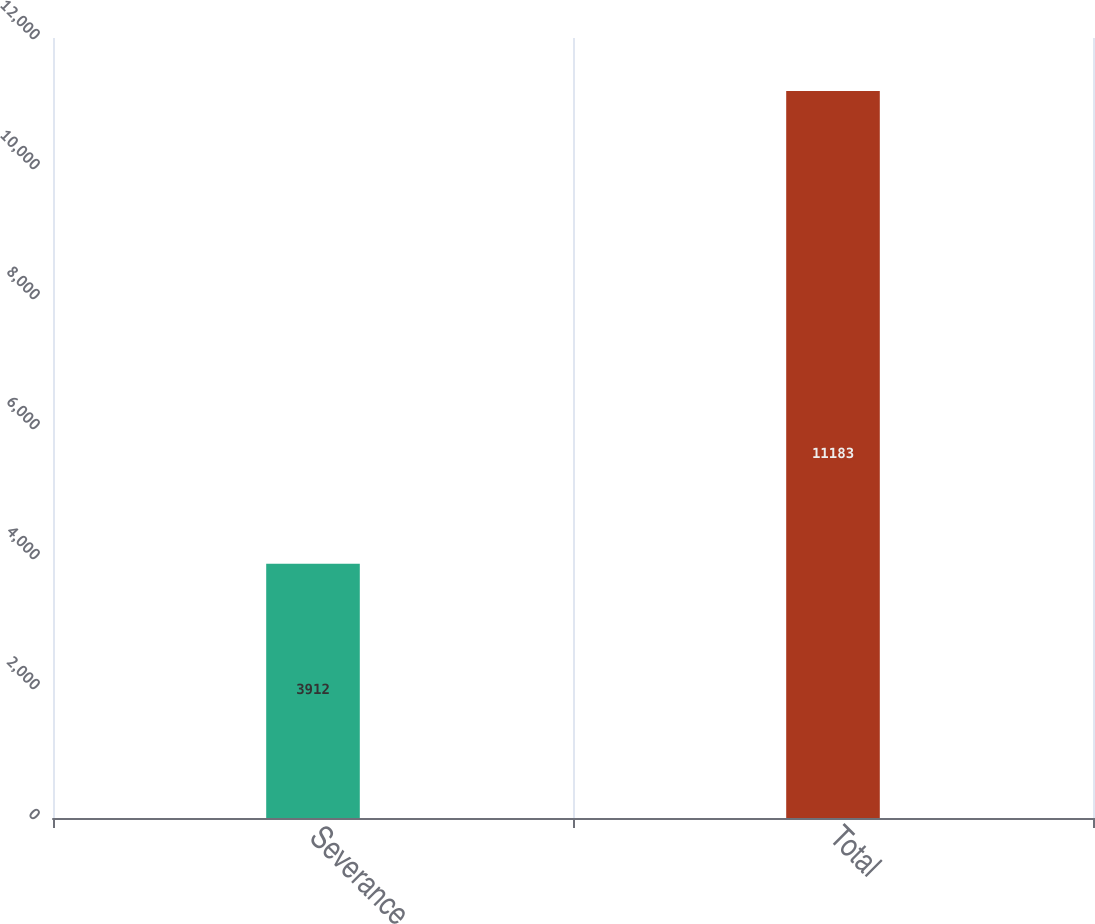Convert chart. <chart><loc_0><loc_0><loc_500><loc_500><bar_chart><fcel>Severance<fcel>Total<nl><fcel>3912<fcel>11183<nl></chart> 